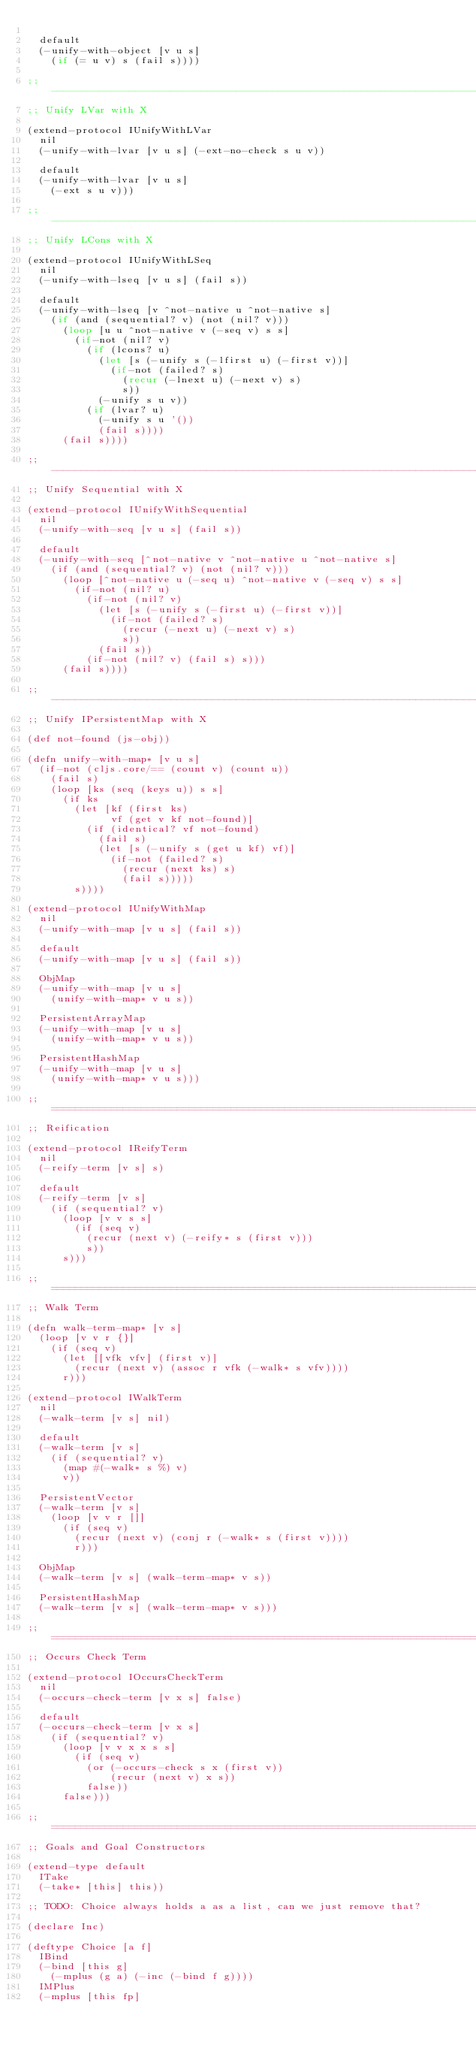Convert code to text. <code><loc_0><loc_0><loc_500><loc_500><_Clojure_>
  default
  (-unify-with-object [v u s]
    (if (= u v) s (fail s))))

;; -----------------------------------------------------------------------------
;; Unify LVar with X

(extend-protocol IUnifyWithLVar
  nil
  (-unify-with-lvar [v u s] (-ext-no-check s u v))

  default
  (-unify-with-lvar [v u s]
    (-ext s u v)))

;; -----------------------------------------------------------------------------
;; Unify LCons with X

(extend-protocol IUnifyWithLSeq
  nil
  (-unify-with-lseq [v u s] (fail s))

  default
  (-unify-with-lseq [v ^not-native u ^not-native s]
    (if (and (sequential? v) (not (nil? v)))
      (loop [u u ^not-native v (-seq v) s s]
        (if-not (nil? v)
          (if (lcons? u)
            (let [s (-unify s (-lfirst u) (-first v))]
              (if-not (failed? s)
                (recur (-lnext u) (-next v) s)
                s))
            (-unify s u v))
          (if (lvar? u)
            (-unify s u '())
            (fail s))))
      (fail s))))

;; -----------------------------------------------------------------------------
;; Unify Sequential with X

(extend-protocol IUnifyWithSequential
  nil
  (-unify-with-seq [v u s] (fail s))

  default
  (-unify-with-seq [^not-native v ^not-native u ^not-native s]
    (if (and (sequential? v) (not (nil? v)))
      (loop [^not-native u (-seq u) ^not-native v (-seq v) s s]
        (if-not (nil? u)
          (if-not (nil? v)
            (let [s (-unify s (-first u) (-first v))]
              (if-not (failed? s)
                (recur (-next u) (-next v) s)
                s))
            (fail s))
          (if-not (nil? v) (fail s) s)))
      (fail s))))

;; -----------------------------------------------------------------------------
;; Unify IPersistentMap with X

(def not-found (js-obj))

(defn unify-with-map* [v u s]
  (if-not (cljs.core/== (count v) (count u))
    (fail s)
    (loop [ks (seq (keys u)) s s]
      (if ks
        (let [kf (first ks)
              vf (get v kf not-found)]
          (if (identical? vf not-found)
            (fail s)
            (let [s (-unify s (get u kf) vf)]
              (if-not (failed? s)
                (recur (next ks) s)
                (fail s)))))
        s))))

(extend-protocol IUnifyWithMap
  nil
  (-unify-with-map [v u s] (fail s))

  default
  (-unify-with-map [v u s] (fail s))

  ObjMap
  (-unify-with-map [v u s]
    (unify-with-map* v u s))

  PersistentArrayMap
  (-unify-with-map [v u s]
    (unify-with-map* v u s))

  PersistentHashMap
  (-unify-with-map [v u s]
    (unify-with-map* v u s)))

;; =============================================================================
;; Reification

(extend-protocol IReifyTerm
  nil
  (-reify-term [v s] s)

  default
  (-reify-term [v s]
    (if (sequential? v)
      (loop [v v s s]
        (if (seq v)
          (recur (next v) (-reify* s (first v)))
          s))
      s)))

;; =============================================================================
;; Walk Term

(defn walk-term-map* [v s]
  (loop [v v r {}]
    (if (seq v)
      (let [[vfk vfv] (first v)]
        (recur (next v) (assoc r vfk (-walk* s vfv))))
      r)))

(extend-protocol IWalkTerm
  nil
  (-walk-term [v s] nil)

  default
  (-walk-term [v s]
    (if (sequential? v)
      (map #(-walk* s %) v)
      v))

  PersistentVector
  (-walk-term [v s]
    (loop [v v r []]
      (if (seq v)
        (recur (next v) (conj r (-walk* s (first v))))
        r)))

  ObjMap
  (-walk-term [v s] (walk-term-map* v s))

  PersistentHashMap
  (-walk-term [v s] (walk-term-map* v s)))

;; =============================================================================
;; Occurs Check Term

(extend-protocol IOccursCheckTerm
  nil
  (-occurs-check-term [v x s] false)

  default
  (-occurs-check-term [v x s]
    (if (sequential? v)
      (loop [v v x x s s]
        (if (seq v)
          (or (-occurs-check s x (first v))
              (recur (next v) x s))
          false))
      false)))

;; =============================================================================
;; Goals and Goal Constructors

(extend-type default
  ITake
  (-take* [this] this))

;; TODO: Choice always holds a as a list, can we just remove that?

(declare Inc)

(deftype Choice [a f]
  IBind
  (-bind [this g]
    (-mplus (g a) (-inc (-bind f g))))
  IMPlus
  (-mplus [this fp]</code> 